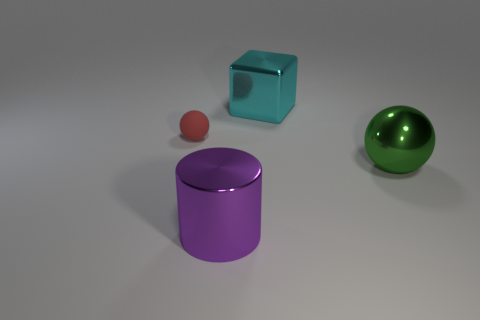The cyan object that is the same material as the big purple cylinder is what size?
Ensure brevity in your answer.  Large. What is the color of the large shiny ball?
Keep it short and to the point. Green. How many metallic spheres have the same color as the metallic block?
Give a very brief answer. 0. What material is the sphere that is the same size as the cyan shiny block?
Offer a terse response. Metal. There is a tiny red sphere that is on the left side of the cyan metal cube; is there a large green metallic object that is to the left of it?
Your answer should be compact. No. What number of other objects are there of the same color as the metallic sphere?
Your answer should be compact. 0. What is the size of the green object?
Provide a succinct answer. Large. Are there any metal cubes?
Ensure brevity in your answer.  Yes. Are there more big shiny objects to the right of the big cyan metal object than purple cylinders that are in front of the purple thing?
Make the answer very short. Yes. What is the material of the large thing that is in front of the metal block and to the left of the green object?
Make the answer very short. Metal. 